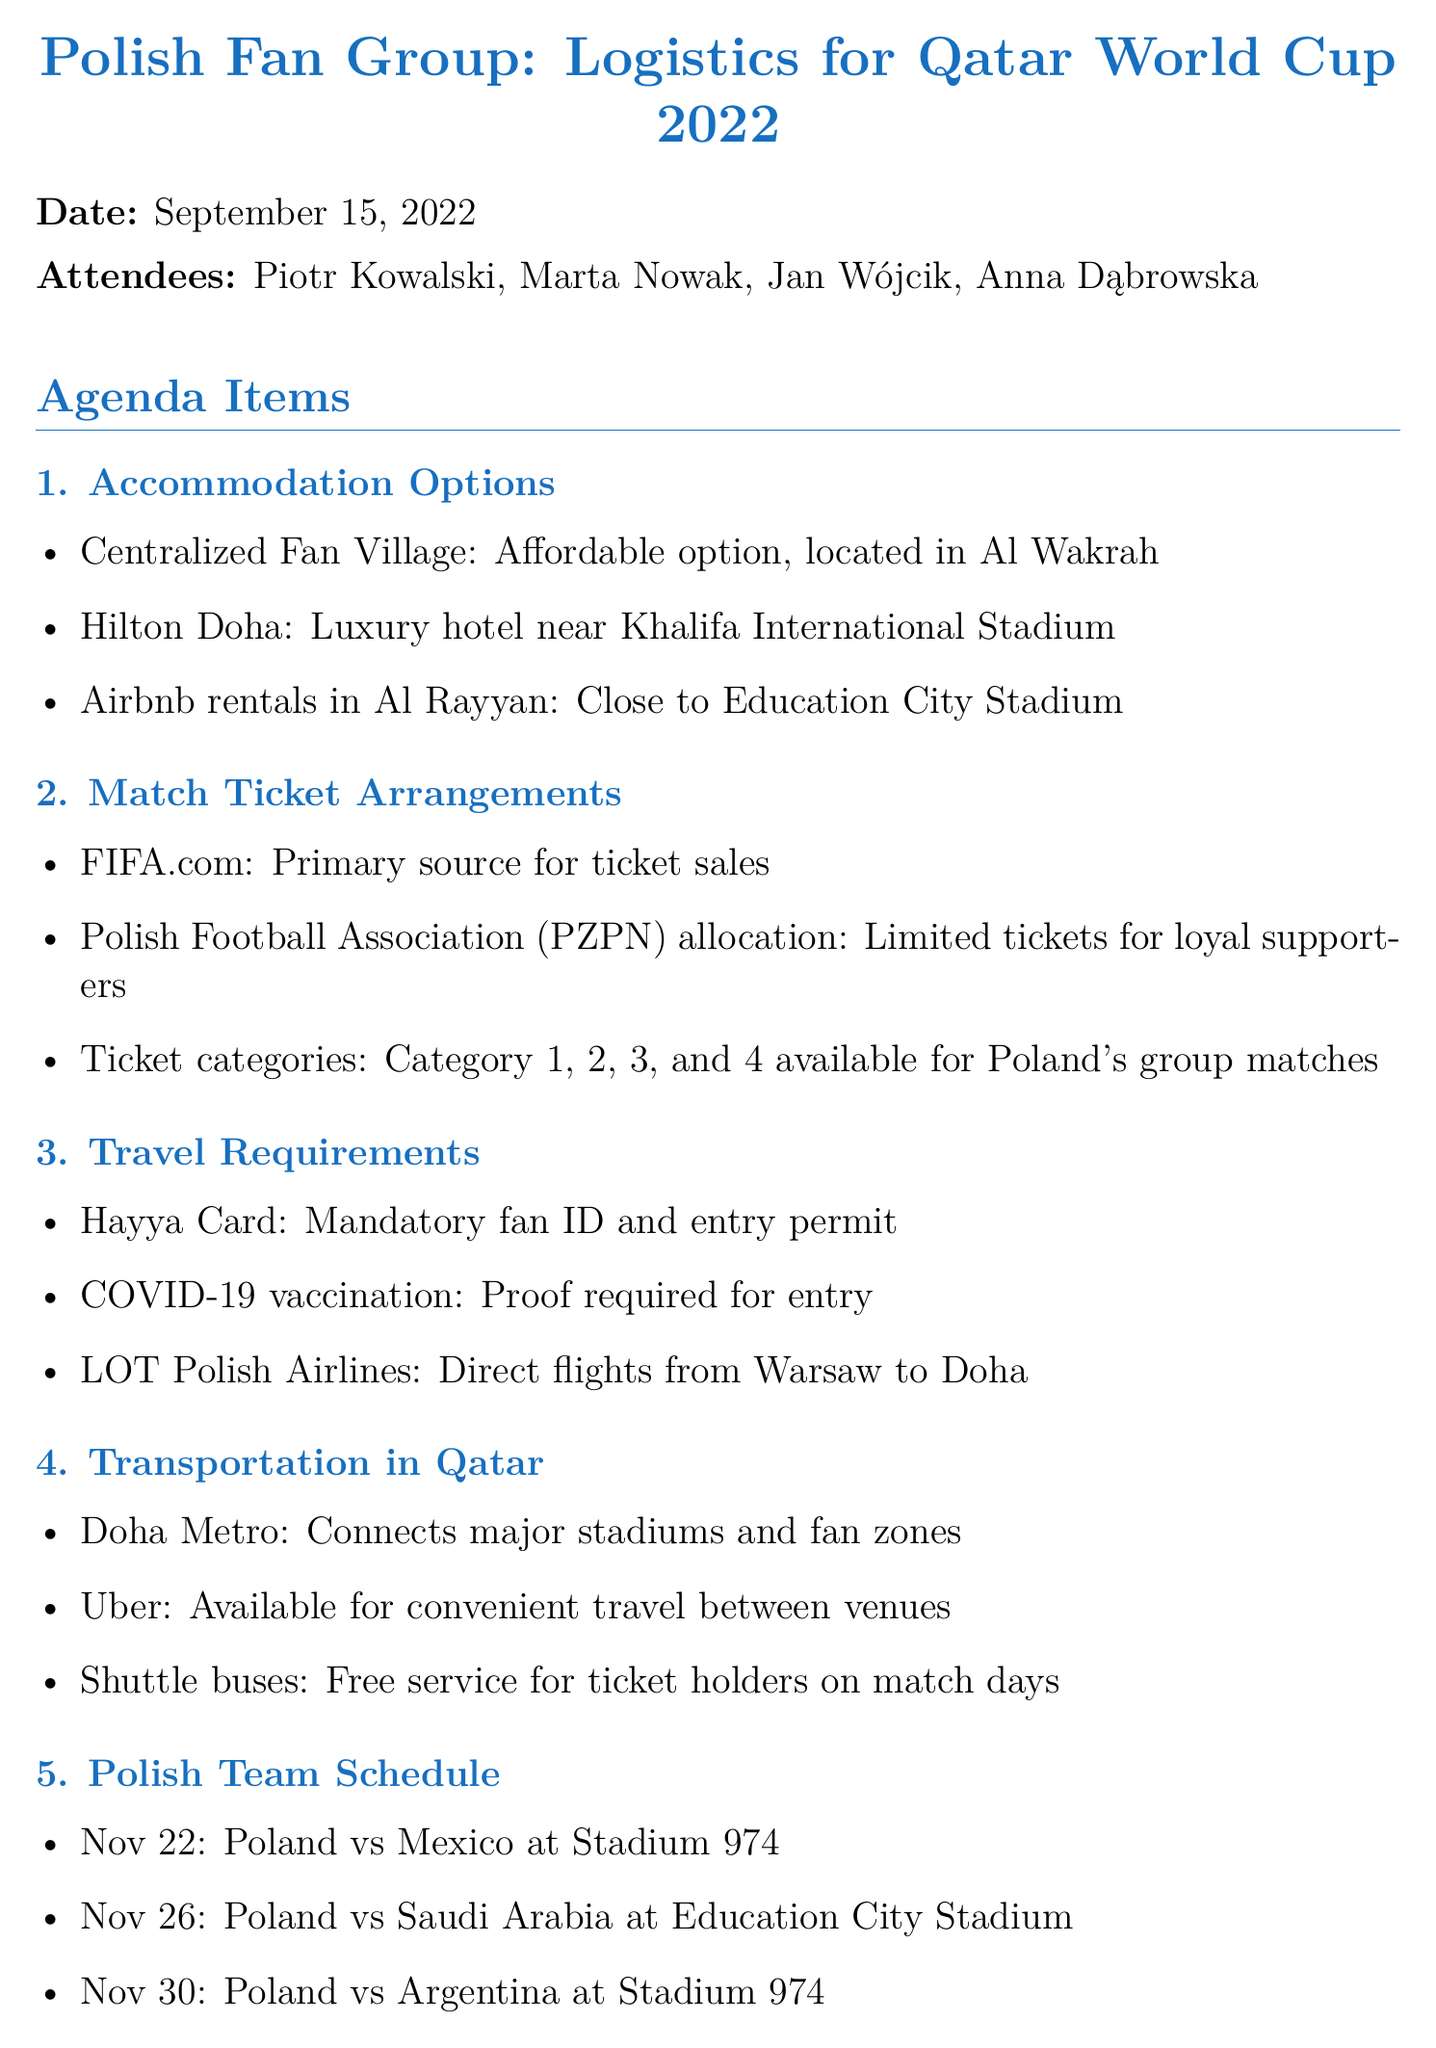What is the date of the meeting? The date of the meeting is explicitly stated in the document.
Answer: September 15, 2022 Who is one of the attendees? The document lists the attendees at the beginning.
Answer: Piotr Kowalski What is the luxury accommodation option mentioned? The document provides specific options under accommodation, including luxury choices.
Answer: Hilton Doha What is required for entry into Qatar? The travel requirements section mentions specific entry requirements.
Answer: COVID-19 vaccination How many matches are scheduled for Poland? The Polish team schedule lists matches that Poland will play during the World Cup.
Answer: 3 Which airline offers direct flights from Warsaw to Doha? The travel requirements section highlights the airline providing direct flights.
Answer: LOT Polish Airlines Where is the Centralized Fan Village located? The accommodation options detail the location of the Centralized Fan Village.
Answer: Al Wakrah What should be booked through FIFA’s portal? The action items specify what needs to be booked.
Answer: Accommodation 